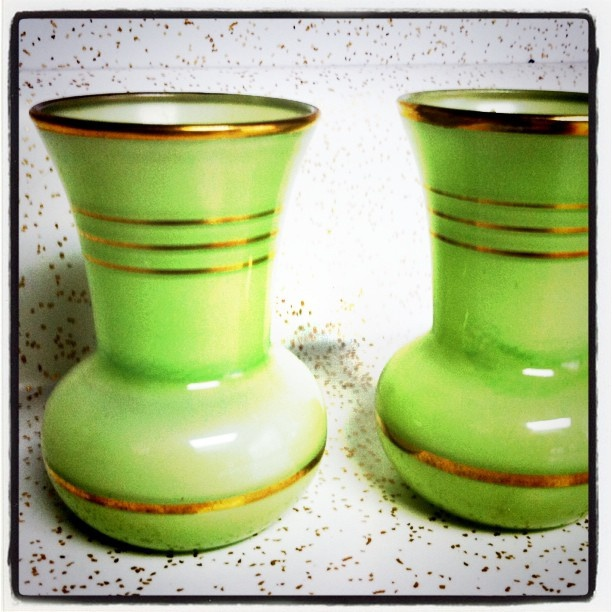Describe the objects in this image and their specific colors. I can see vase in white, lightgreen, khaki, olive, and beige tones and vase in white, olive, lightgreen, darkgreen, and khaki tones in this image. 